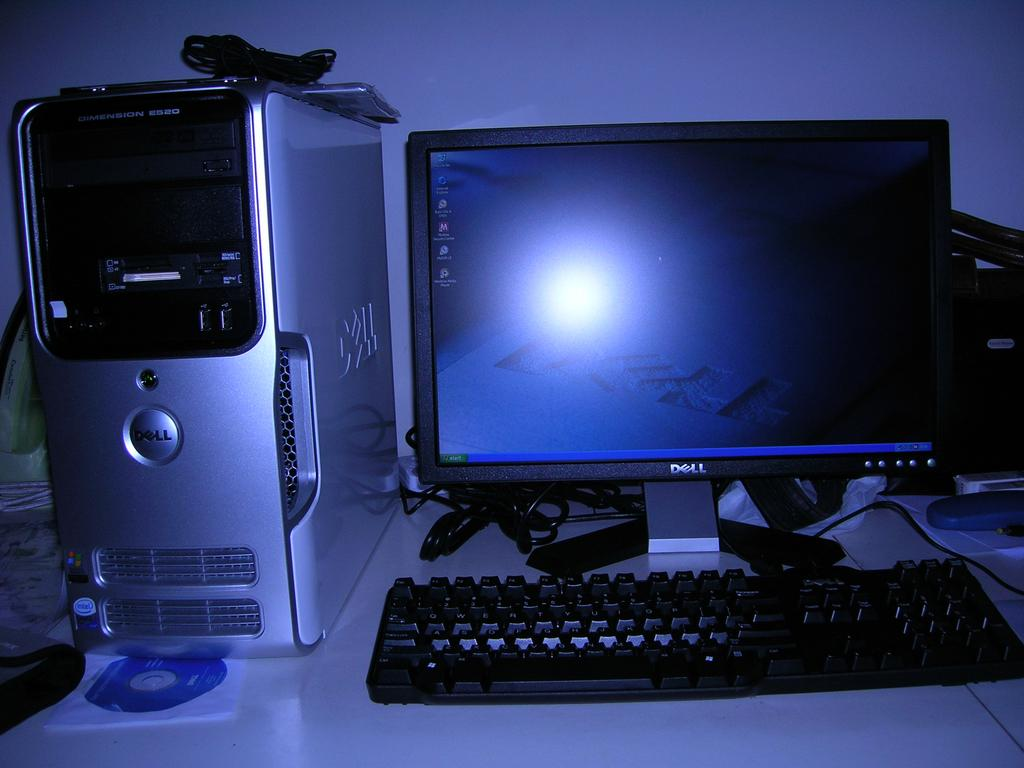Provide a one-sentence caption for the provided image. A Dell computer sitting on a desk with their home screen visible. 